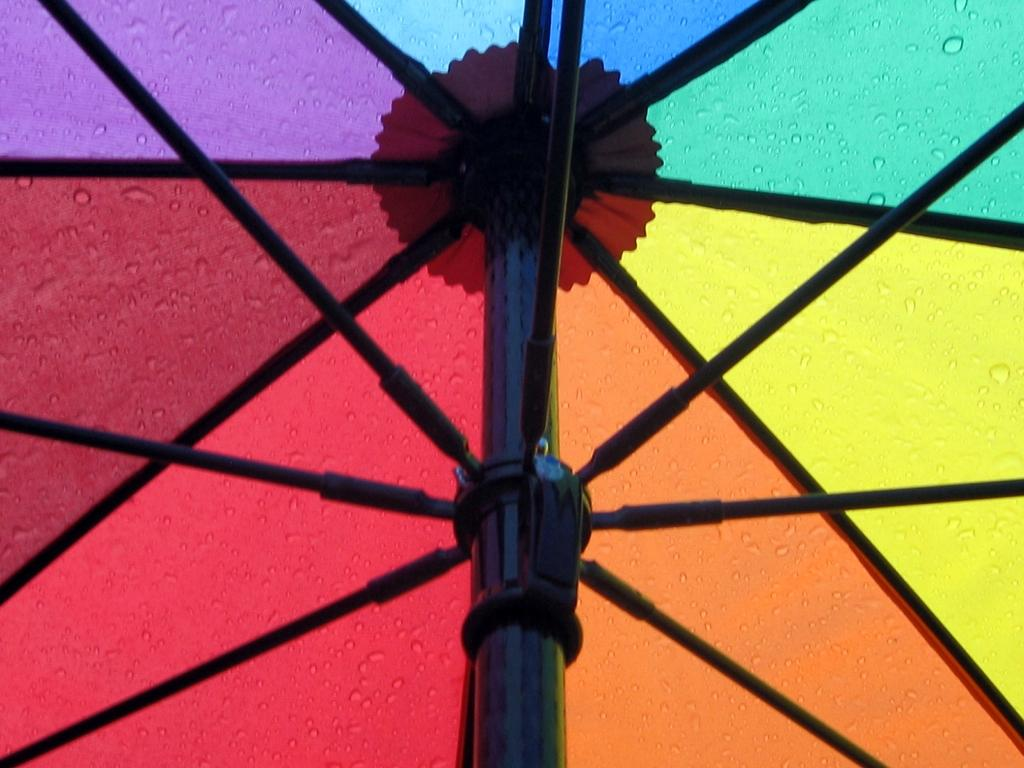What type of objects can be seen in the image? There are metal rods in the image. Can you describe the background of the image? The background of the image is colorful. What type of secretary is present in the image? There is no secretary present in the image; it only features metal rods and a colorful background. 